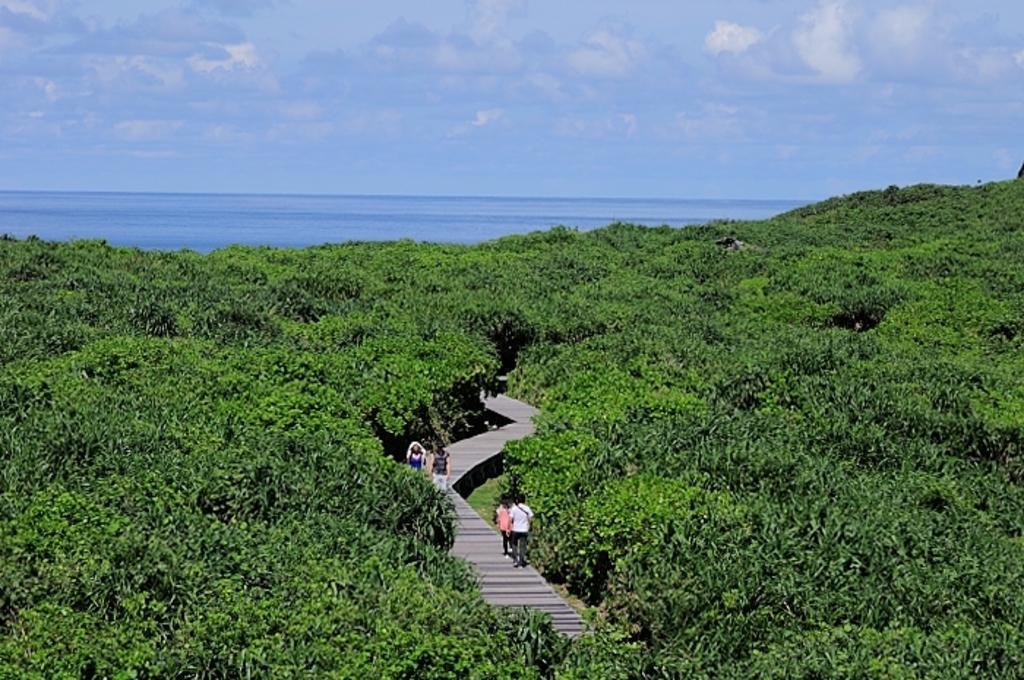Describe this image in one or two sentences. In the center of the image there is a walkway and we can see people. There are trees. In the background there is water and sky. 